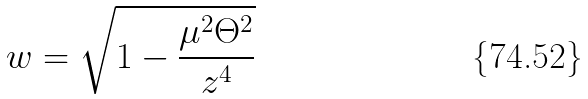Convert formula to latex. <formula><loc_0><loc_0><loc_500><loc_500>w = \sqrt { 1 - \frac { \mu ^ { 2 } \Theta ^ { 2 } } { z ^ { 4 } } }</formula> 